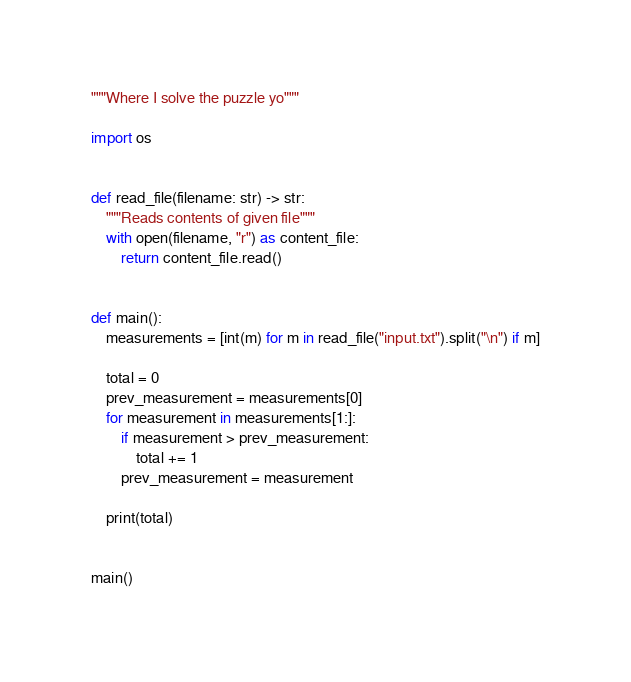<code> <loc_0><loc_0><loc_500><loc_500><_Python_>"""Where I solve the puzzle yo"""

import os


def read_file(filename: str) -> str:
    """Reads contents of given file"""
    with open(filename, "r") as content_file:
        return content_file.read()


def main():
    measurements = [int(m) for m in read_file("input.txt").split("\n") if m]

    total = 0
    prev_measurement = measurements[0]
    for measurement in measurements[1:]:
        if measurement > prev_measurement:
            total += 1
        prev_measurement = measurement

    print(total)


main()
</code> 